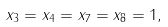Convert formula to latex. <formula><loc_0><loc_0><loc_500><loc_500>x _ { 3 } = x _ { 4 } = x _ { 7 } = x _ { 8 } = 1 ,</formula> 